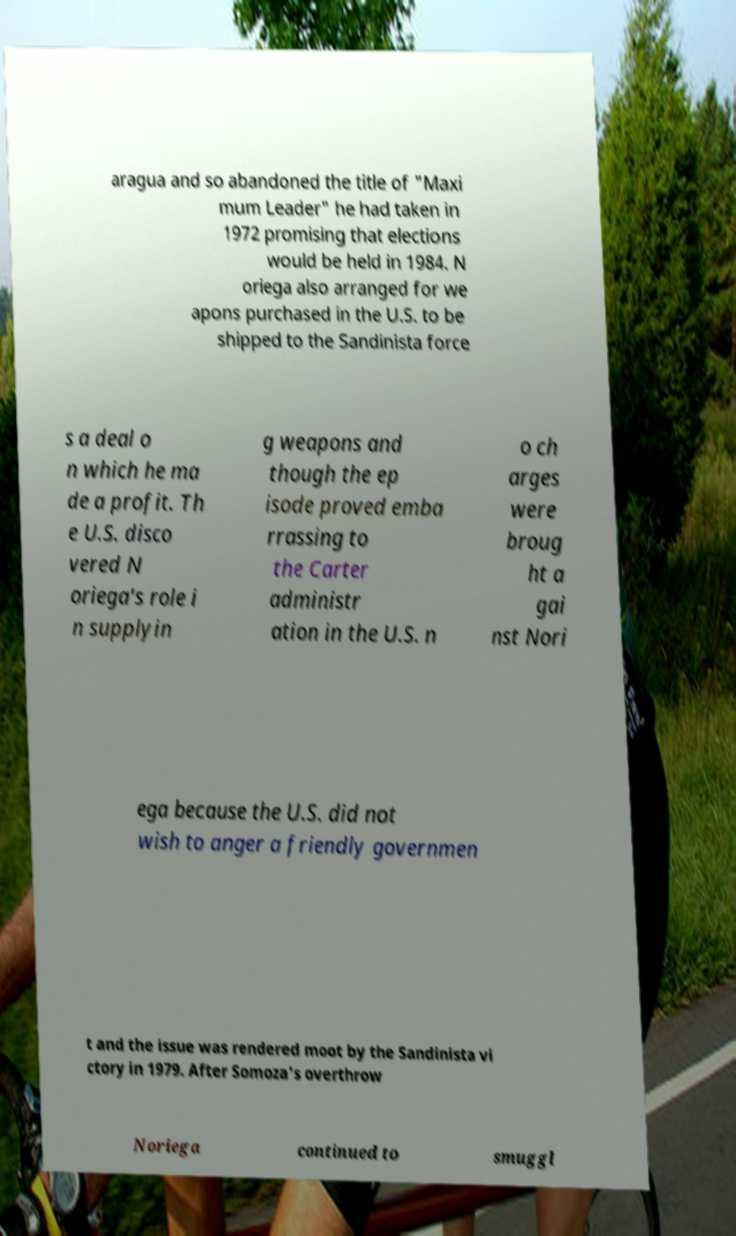I need the written content from this picture converted into text. Can you do that? aragua and so abandoned the title of "Maxi mum Leader" he had taken in 1972 promising that elections would be held in 1984. N oriega also arranged for we apons purchased in the U.S. to be shipped to the Sandinista force s a deal o n which he ma de a profit. Th e U.S. disco vered N oriega's role i n supplyin g weapons and though the ep isode proved emba rrassing to the Carter administr ation in the U.S. n o ch arges were broug ht a gai nst Nori ega because the U.S. did not wish to anger a friendly governmen t and the issue was rendered moot by the Sandinista vi ctory in 1979. After Somoza's overthrow Noriega continued to smuggl 